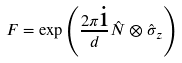<formula> <loc_0><loc_0><loc_500><loc_500>F = \exp \left ( \frac { 2 \pi \text {i} } { d } \hat { N } \otimes \hat { \sigma } _ { z } \right )</formula> 